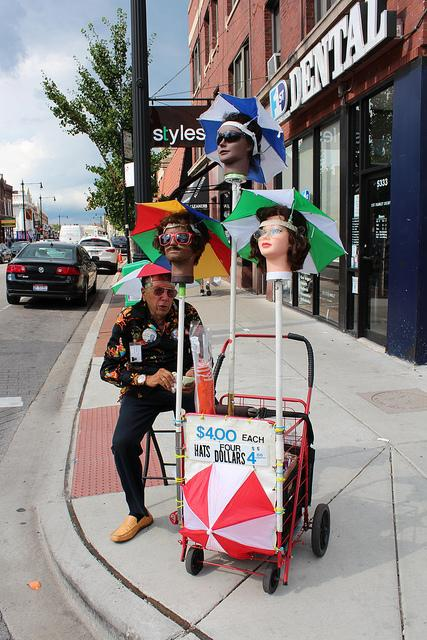What can the clinic on the right help you with? Please explain your reasoning. teeth. Its a dental clinic. 